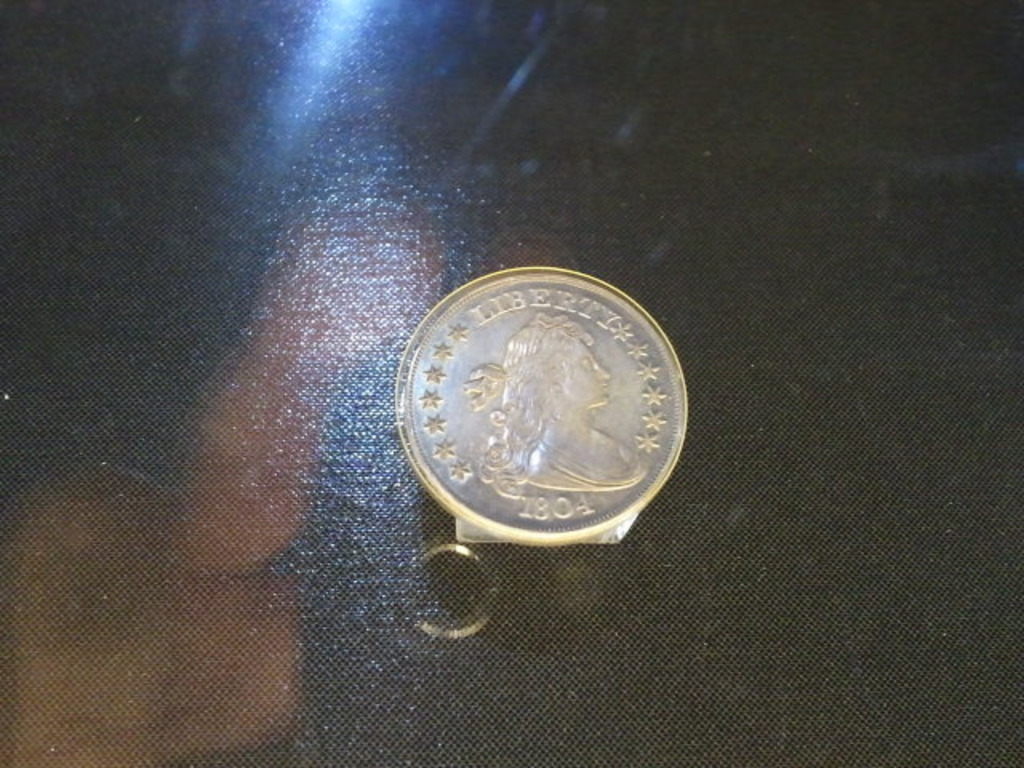Provide a one-sentence caption for the provided image.
Reference OCR token: 1801 The image showcases a coin, possibly a Draped Bust silver dollar, dated 1804, known for its rarity and historical value, displayed on a dark surface with what seems to be a protective case. 